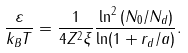<formula> <loc_0><loc_0><loc_500><loc_500>\frac { \varepsilon } { k _ { B } T } = \frac { 1 } { 4 Z ^ { 2 } \xi } \frac { \ln ^ { 2 } \left ( N _ { 0 } / N _ { d } \right ) } { \ln ( 1 + r _ { d } / a ) } .</formula> 